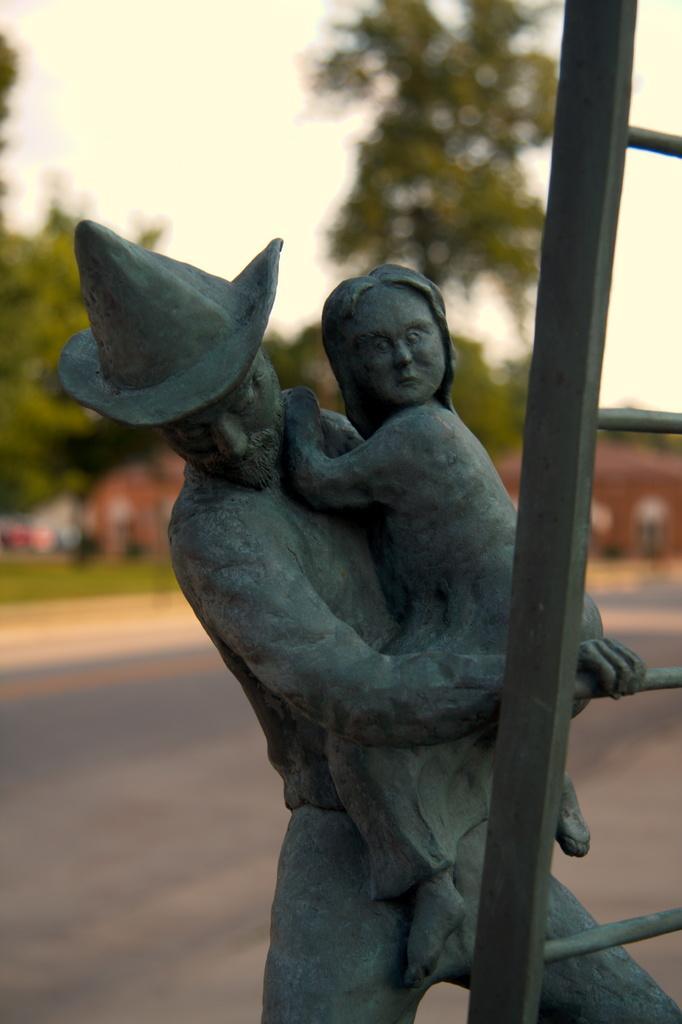How would you summarize this image in a sentence or two? In this image in the front there are statues and there is a ladder. In the background there is grass on the ground, there are trees and there is a building which is red in colour. 